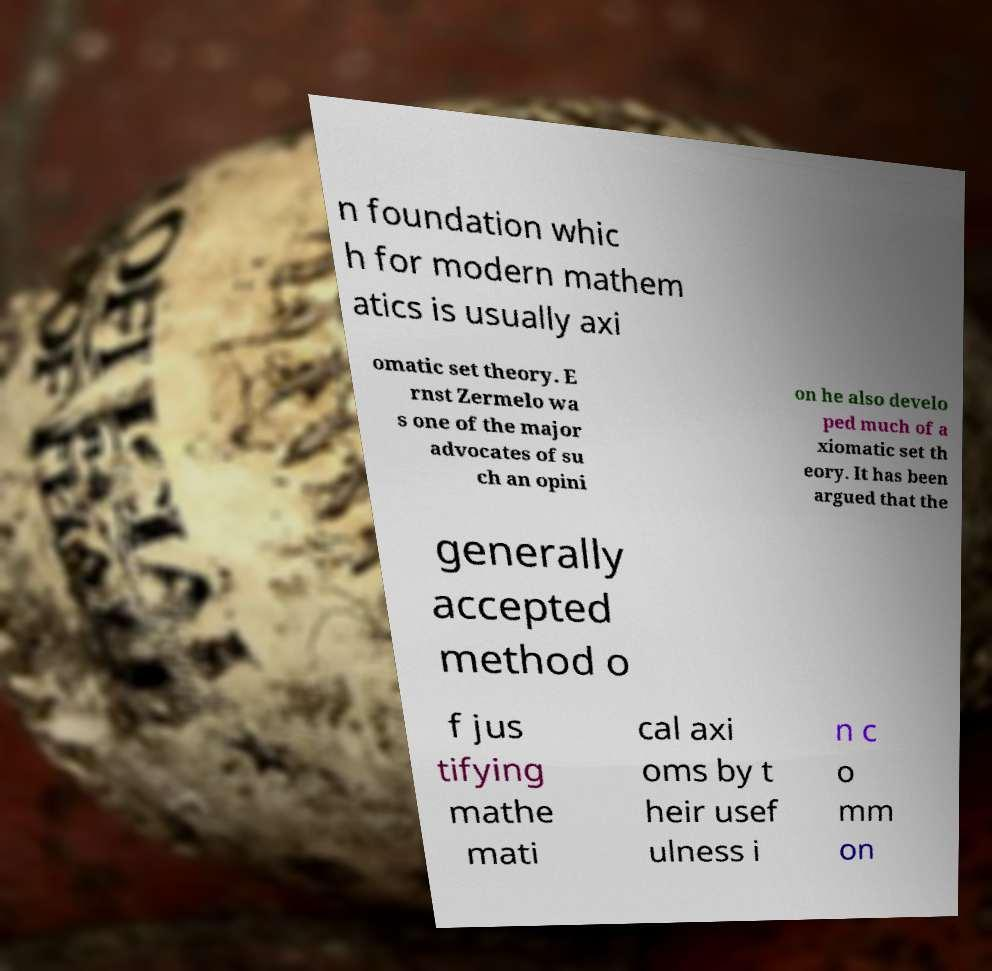Can you accurately transcribe the text from the provided image for me? n foundation whic h for modern mathem atics is usually axi omatic set theory. E rnst Zermelo wa s one of the major advocates of su ch an opini on he also develo ped much of a xiomatic set th eory. It has been argued that the generally accepted method o f jus tifying mathe mati cal axi oms by t heir usef ulness i n c o mm on 